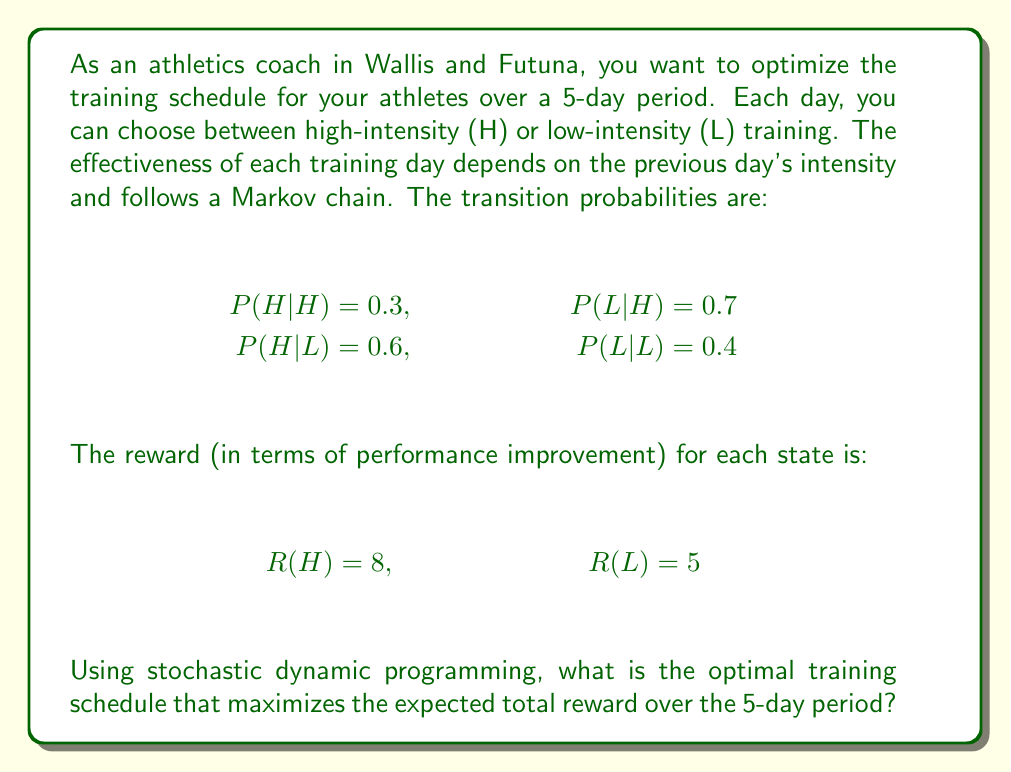Can you answer this question? To solve this problem, we'll use the Bellman equation and work backwards from the last day to the first day. Let $V_t(s)$ be the maximum expected reward from day $t$ to day 5, given that we start in state $s$ on day $t$.

Step 1: Initialize the value function for day 5 (last day)
$$V_5(H) = 8, V_5(L) = 5$$

Step 2: Calculate the value function for days 4 to 1
For $t = 4, 3, 2, 1$:

$$V_t(H) = \max \begin{cases}
8 + 0.3V_{t+1}(H) + 0.7V_{t+1}(L) & \text{if choose H}\\
5 + 0.6V_{t+1}(H) + 0.4V_{t+1}(L) & \text{if choose L}
\end{cases}$$

$$V_t(L) = \max \begin{cases}
8 + 0.3V_{t+1}(H) + 0.7V_{t+1}(L) & \text{if choose H}\\
5 + 0.6V_{t+1}(H) + 0.4V_{t+1}(L) & \text{if choose L}
\end{cases}$$

Step 3: Calculate backwards
Day 4:
$V_4(H) = \max(8 + 0.3 \cdot 8 + 0.7 \cdot 5, 5 + 0.6 \cdot 8 + 0.4 \cdot 5) = \max(11.9, 9.8) = 11.9$ (choose H)
$V_4(L) = \max(8 + 0.3 \cdot 8 + 0.7 \cdot 5, 5 + 0.6 \cdot 8 + 0.4 \cdot 5) = \max(11.9, 9.8) = 11.9$ (choose H)

Day 3:
$V_3(H) = \max(8 + 0.3 \cdot 11.9 + 0.7 \cdot 11.9, 5 + 0.6 \cdot 11.9 + 0.4 \cdot 11.9) = \max(19.9, 16.9) = 19.9$ (choose H)
$V_3(L) = \max(8 + 0.3 \cdot 11.9 + 0.7 \cdot 11.9, 5 + 0.6 \cdot 11.9 + 0.4 \cdot 11.9) = \max(19.9, 16.9) = 19.9$ (choose H)

Day 2:
$V_2(H) = \max(8 + 0.3 \cdot 19.9 + 0.7 \cdot 19.9, 5 + 0.6 \cdot 19.9 + 0.4 \cdot 19.9) = \max(27.9, 24.9) = 27.9$ (choose H)
$V_2(L) = \max(8 + 0.3 \cdot 19.9 + 0.7 \cdot 19.9, 5 + 0.6 \cdot 19.9 + 0.4 \cdot 19.9) = \max(27.9, 24.9) = 27.9$ (choose H)

Day 1:
$V_1(H) = \max(8 + 0.3 \cdot 27.9 + 0.7 \cdot 27.9, 5 + 0.6 \cdot 27.9 + 0.4 \cdot 27.9) = \max(35.9, 32.9) = 35.9$ (choose H)
$V_1(L) = \max(8 + 0.3 \cdot 27.9 + 0.7 \cdot 27.9, 5 + 0.6 \cdot 27.9 + 0.4 \cdot 27.9) = \max(35.9, 32.9) = 35.9$ (choose H)

Step 4: Determine the optimal policy
The optimal policy is to choose high-intensity (H) training every day, regardless of the previous day's intensity.
Answer: H-H-H-H-H 